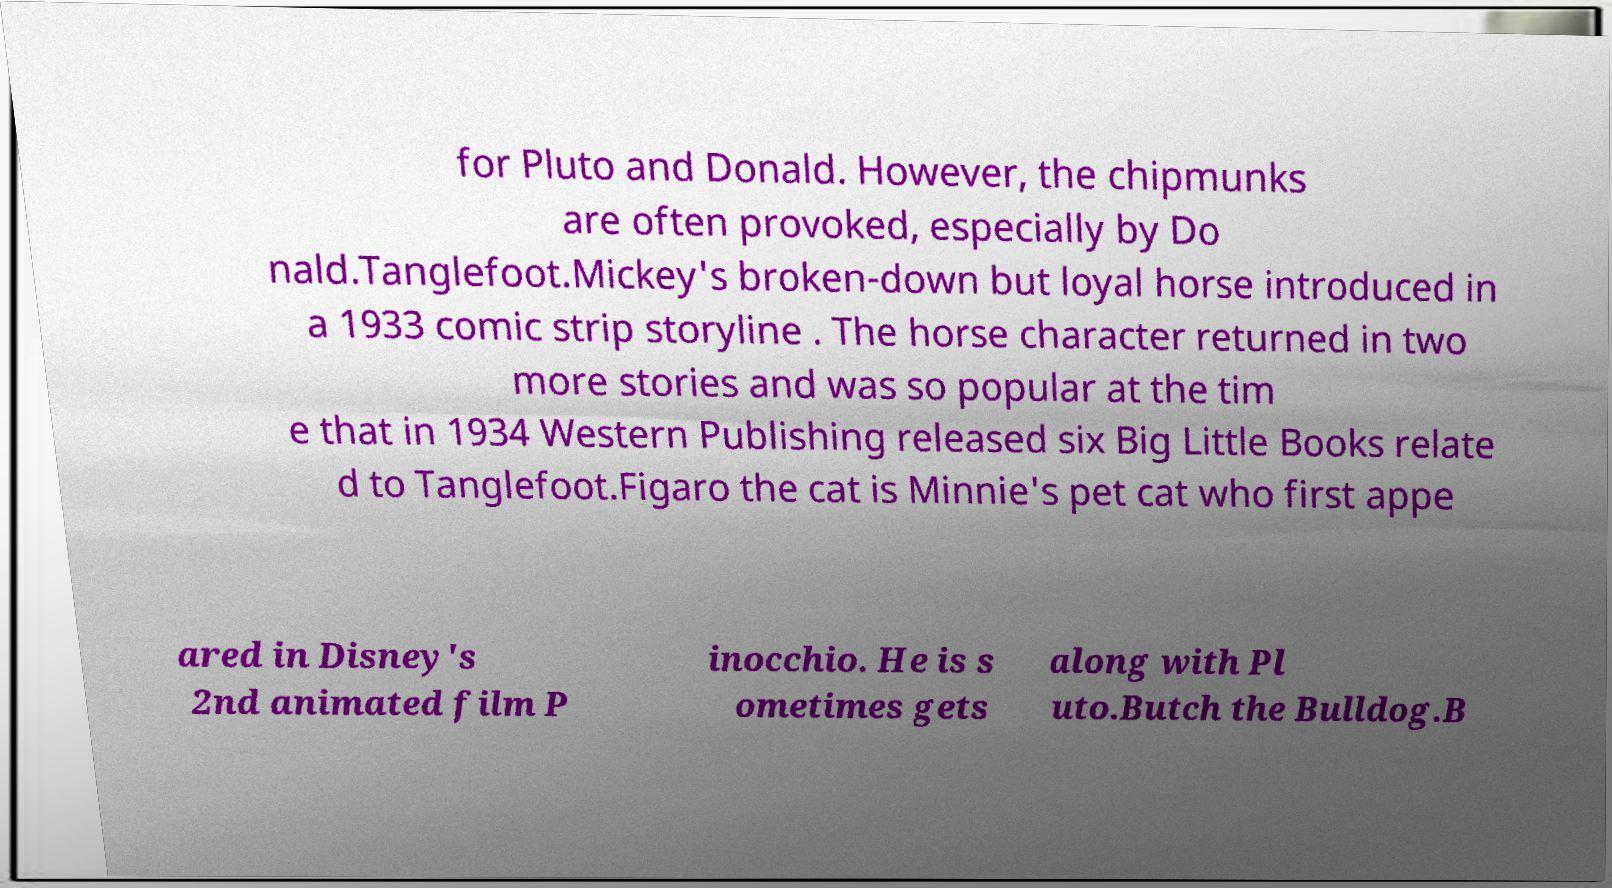Can you read and provide the text displayed in the image?This photo seems to have some interesting text. Can you extract and type it out for me? for Pluto and Donald. However, the chipmunks are often provoked, especially by Do nald.Tanglefoot.Mickey's broken-down but loyal horse introduced in a 1933 comic strip storyline . The horse character returned in two more stories and was so popular at the tim e that in 1934 Western Publishing released six Big Little Books relate d to Tanglefoot.Figaro the cat is Minnie's pet cat who first appe ared in Disney's 2nd animated film P inocchio. He is s ometimes gets along with Pl uto.Butch the Bulldog.B 